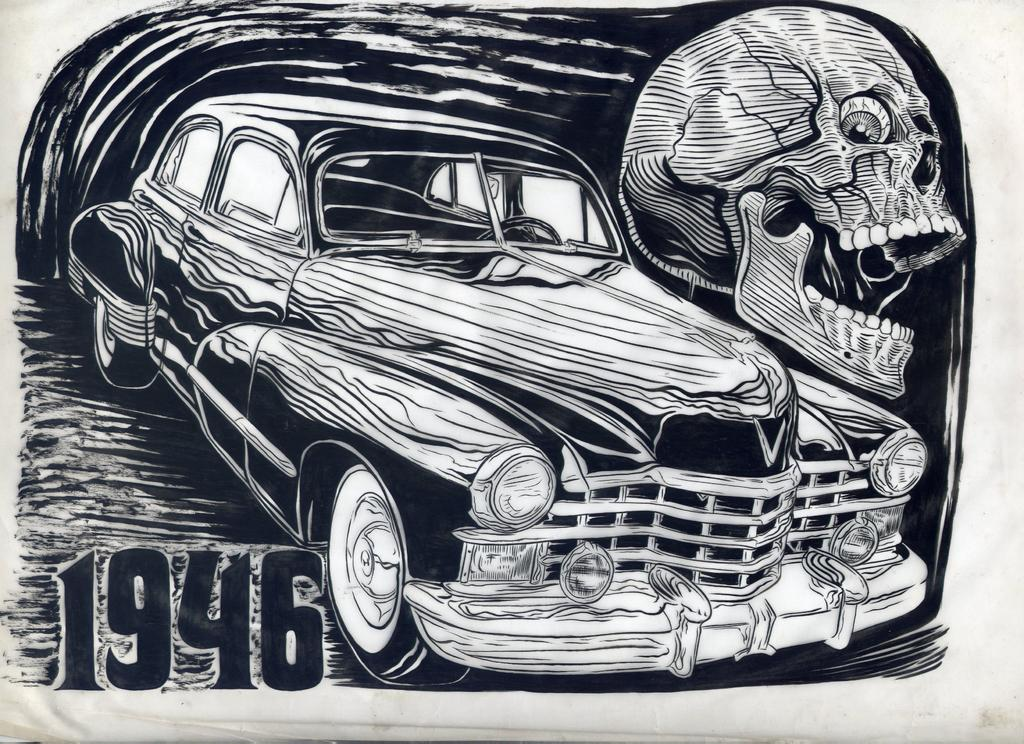What is the main object in the image? There is a paper in the image. What is depicted on the paper? There is a car and a skull diagram on the paper. Is there any text or numbers on the paper? Yes, there is a number on the paper. How many mice are sitting on the cabbage in the image? There are no mice or cabbage present in the image. 